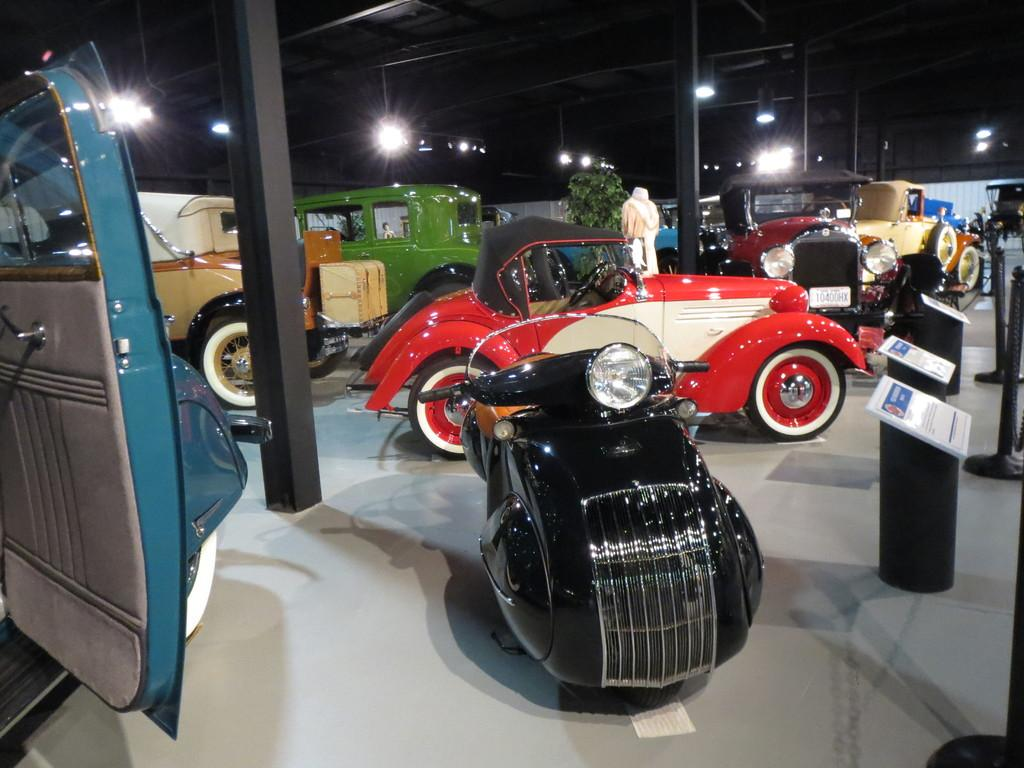What objects are on the floor in the image? There are vehicles on the floor in the image. What can be seen in the background of the image? There are three pillars, lights, a person, and a wall in the background of the image. How many rabbits can be seen thinking hot thoughts in the image? There are no rabbits or thoughts present in the image. 